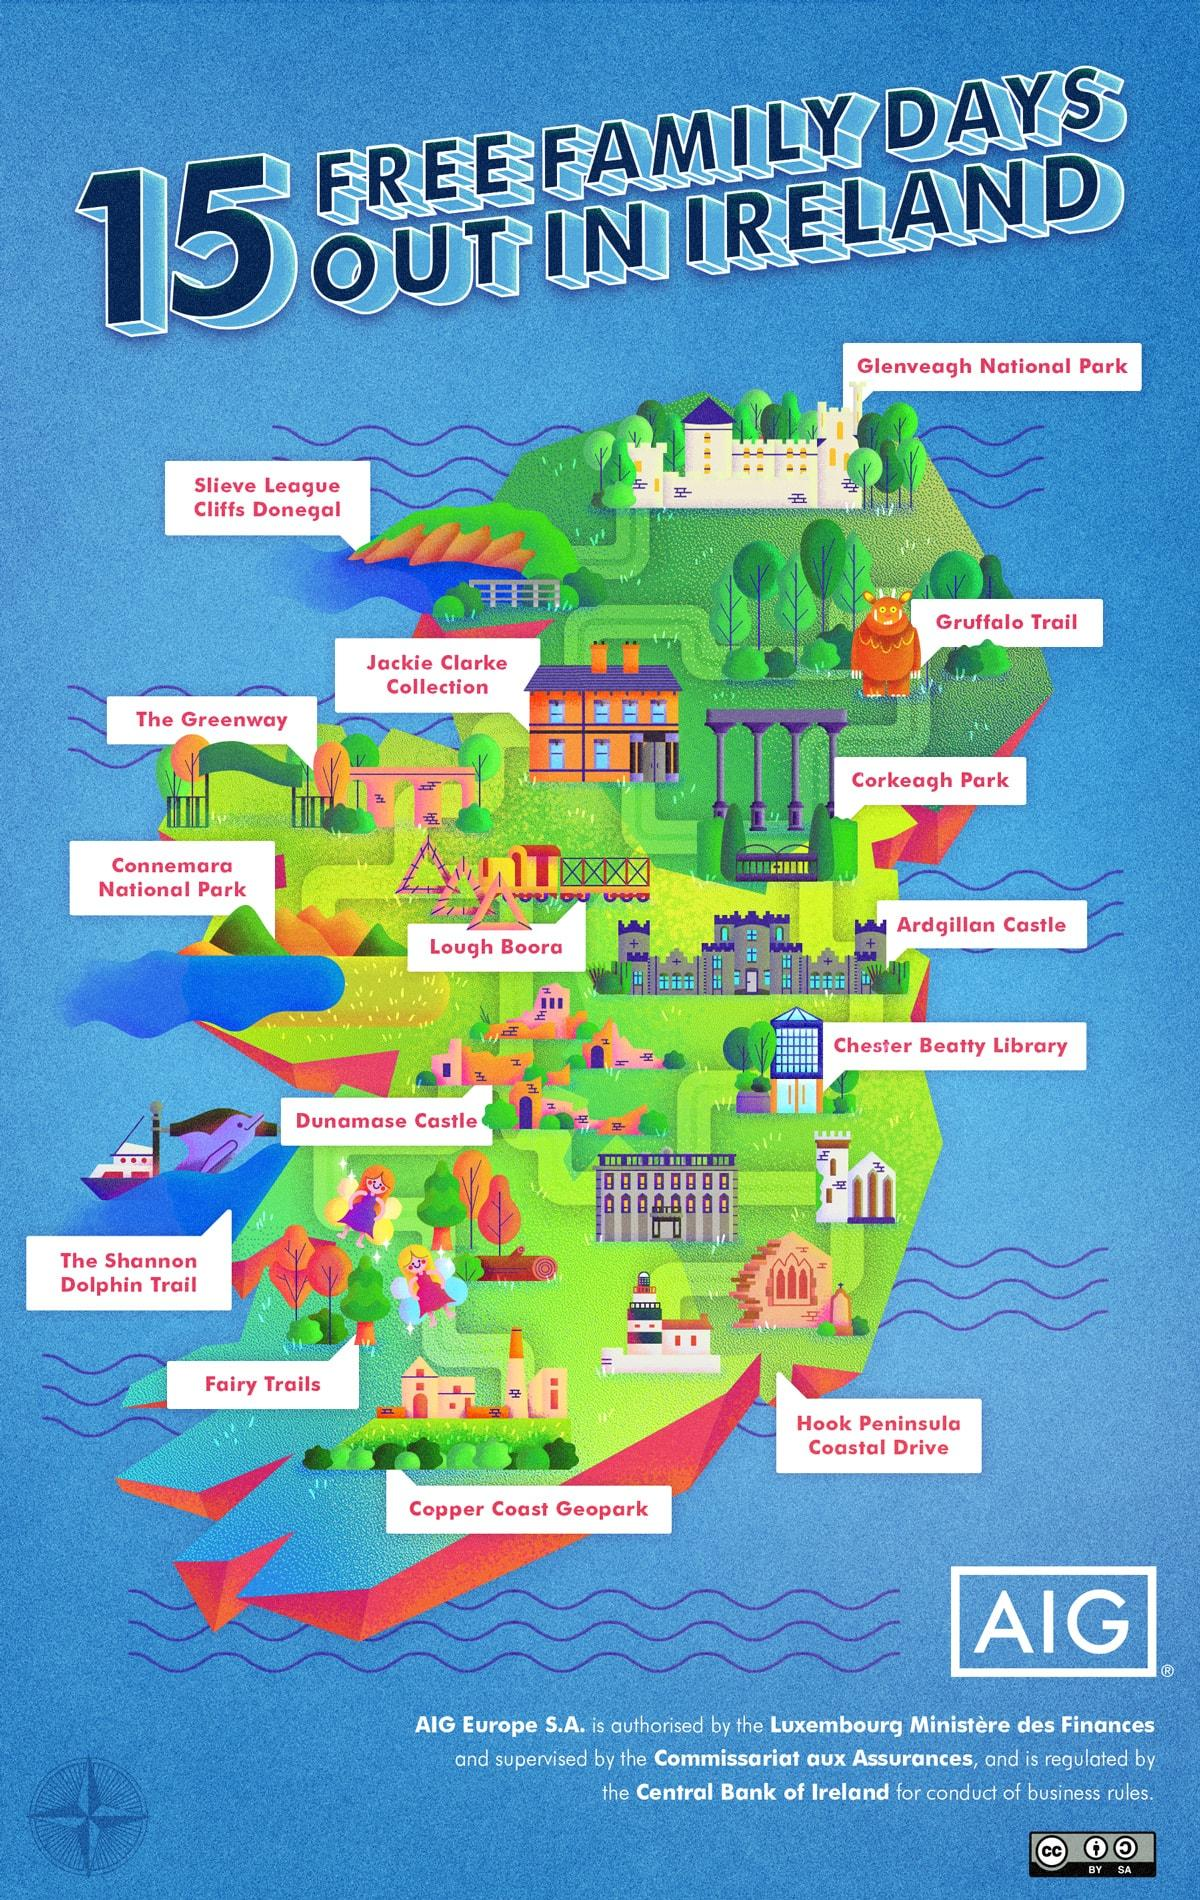Highlight a few significant elements in this photo. There are two national parks in Ireland. There are 4 parks in Ireland. There are three trails in Ireland. 